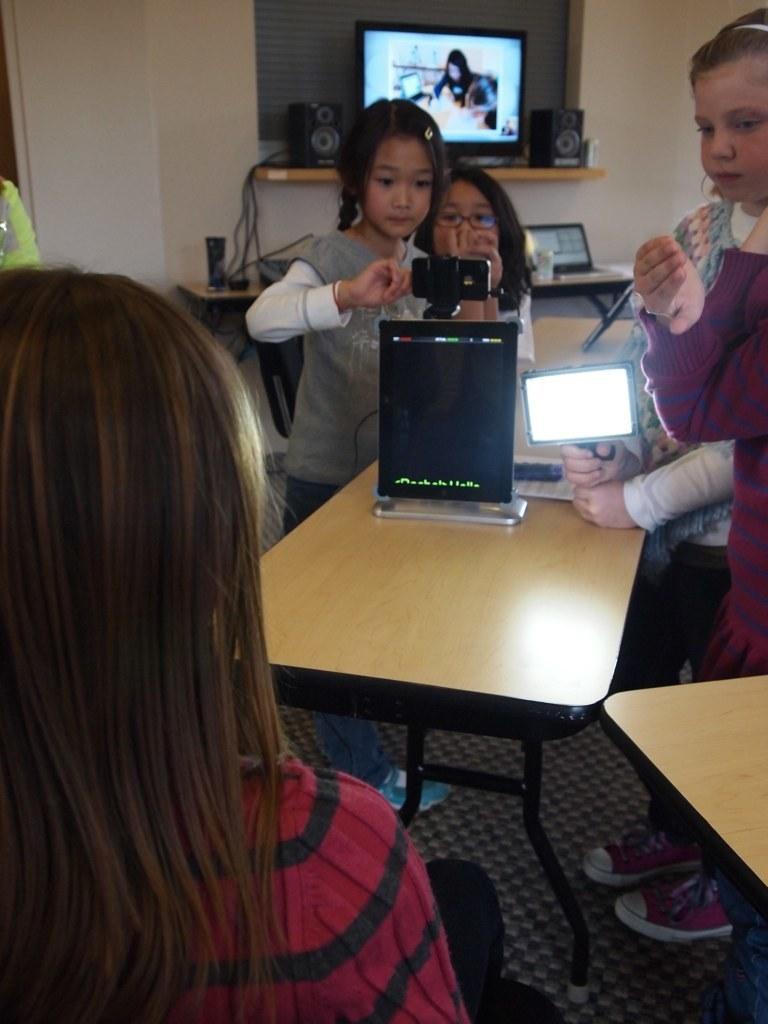Describe this image in one or two sentences. In this picture we can see girls looking at the camera and using light in her hand and ton table we can see some of this items and in background we can see television, speaker,wires and here the girl is watching them. 